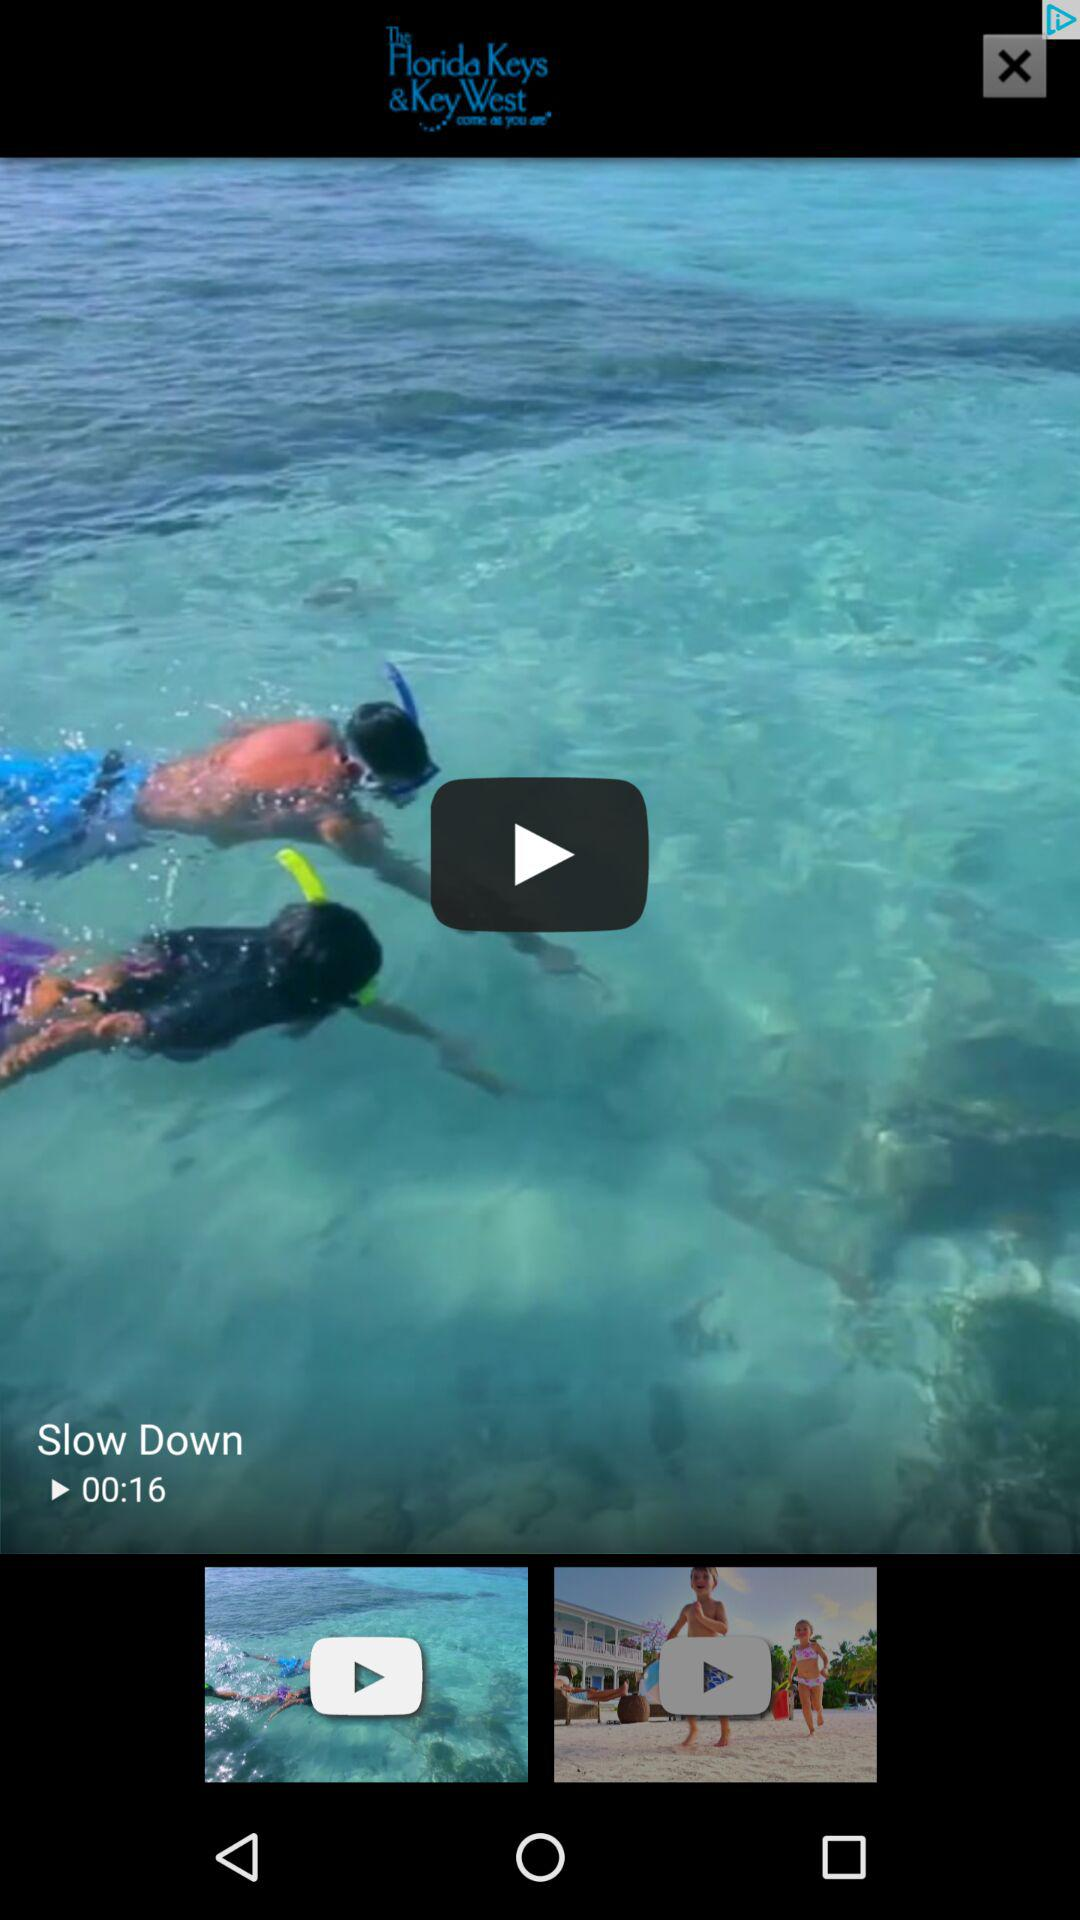What's the name of the video? The name of the video is "Slow Down". 